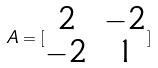<formula> <loc_0><loc_0><loc_500><loc_500>A = [ \begin{matrix} 2 & - 2 \\ - 2 & 1 \end{matrix} ]</formula> 